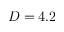Convert formula to latex. <formula><loc_0><loc_0><loc_500><loc_500>D = 4 . 2</formula> 